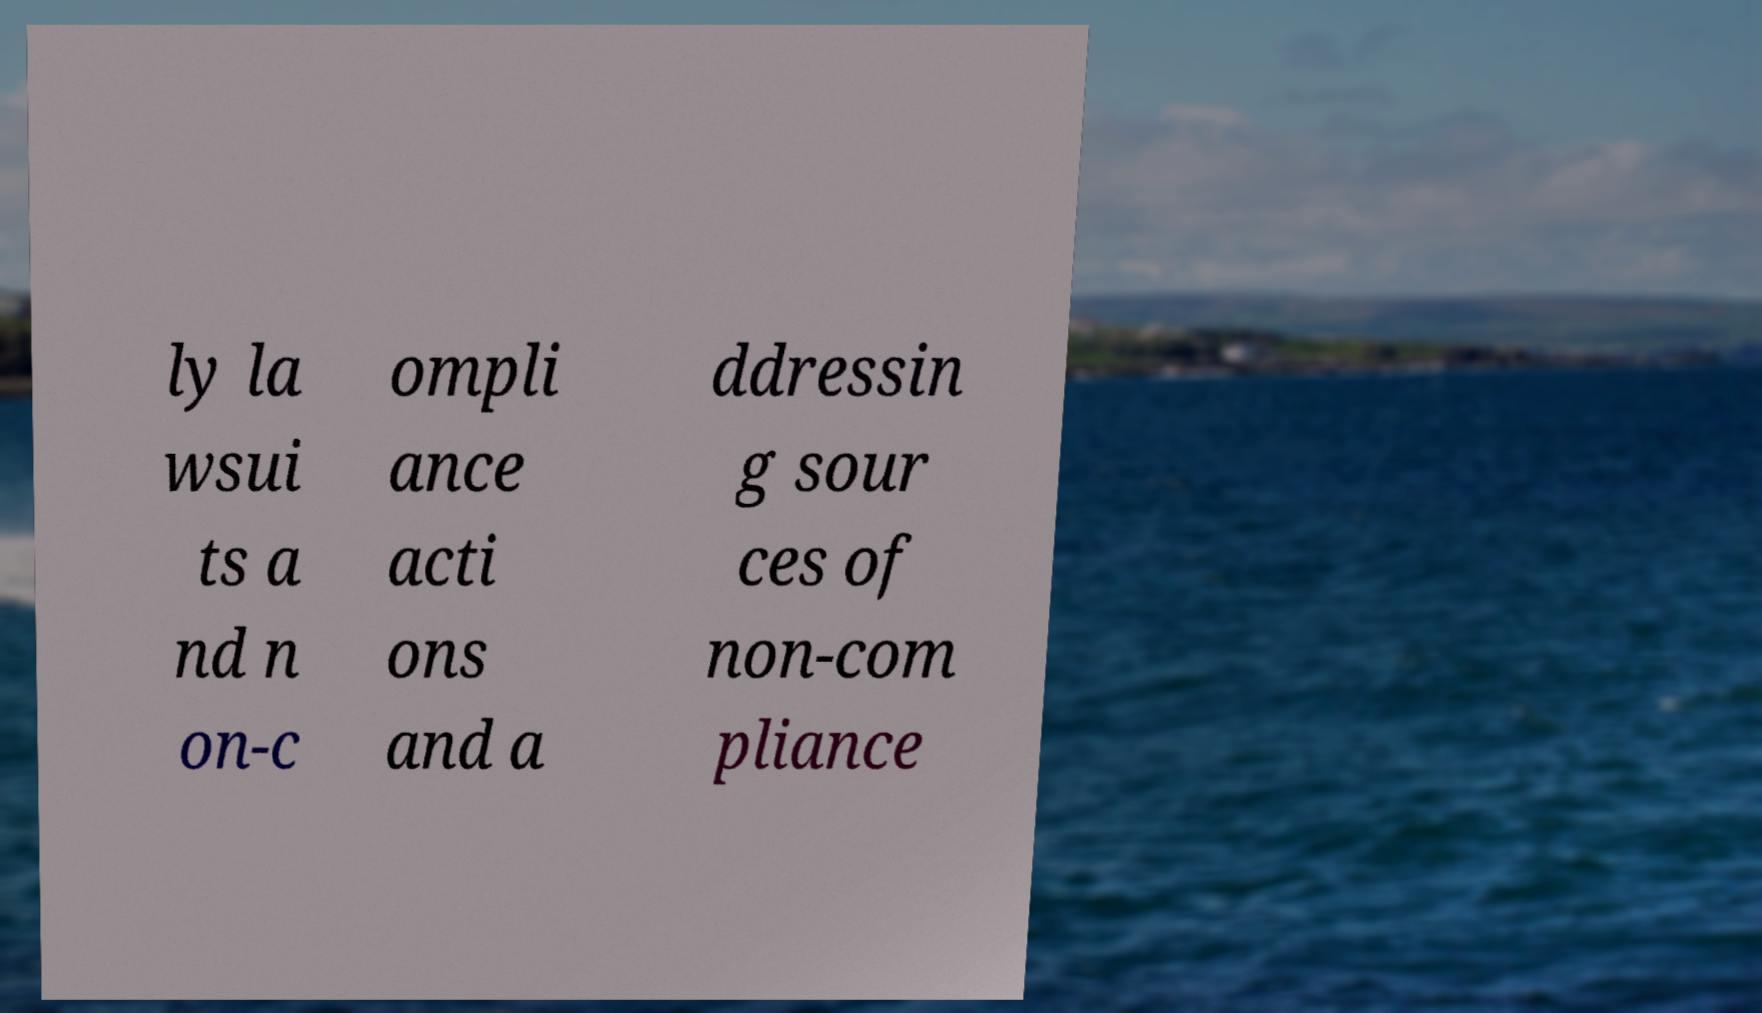Please identify and transcribe the text found in this image. ly la wsui ts a nd n on-c ompli ance acti ons and a ddressin g sour ces of non-com pliance 